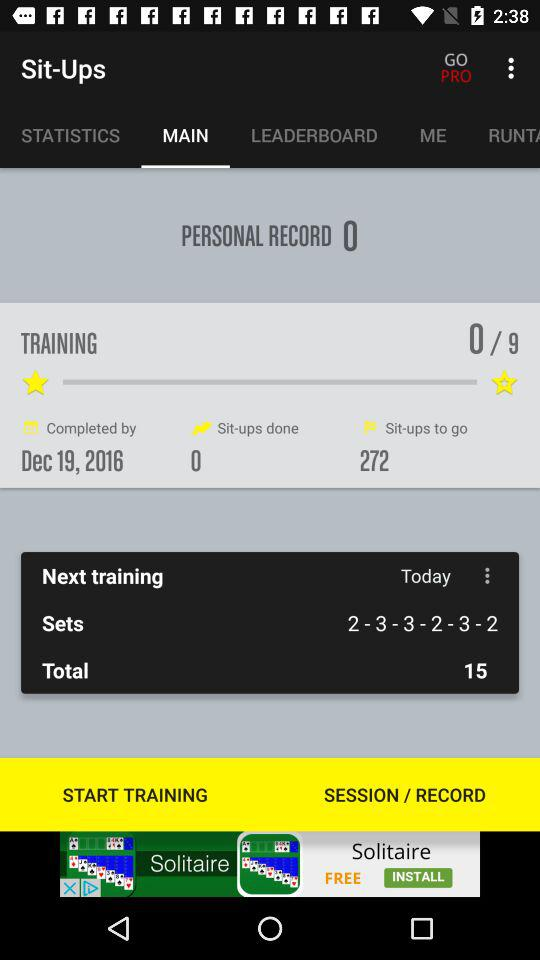Which tab am I on? You are on the "MAIN" tab. 